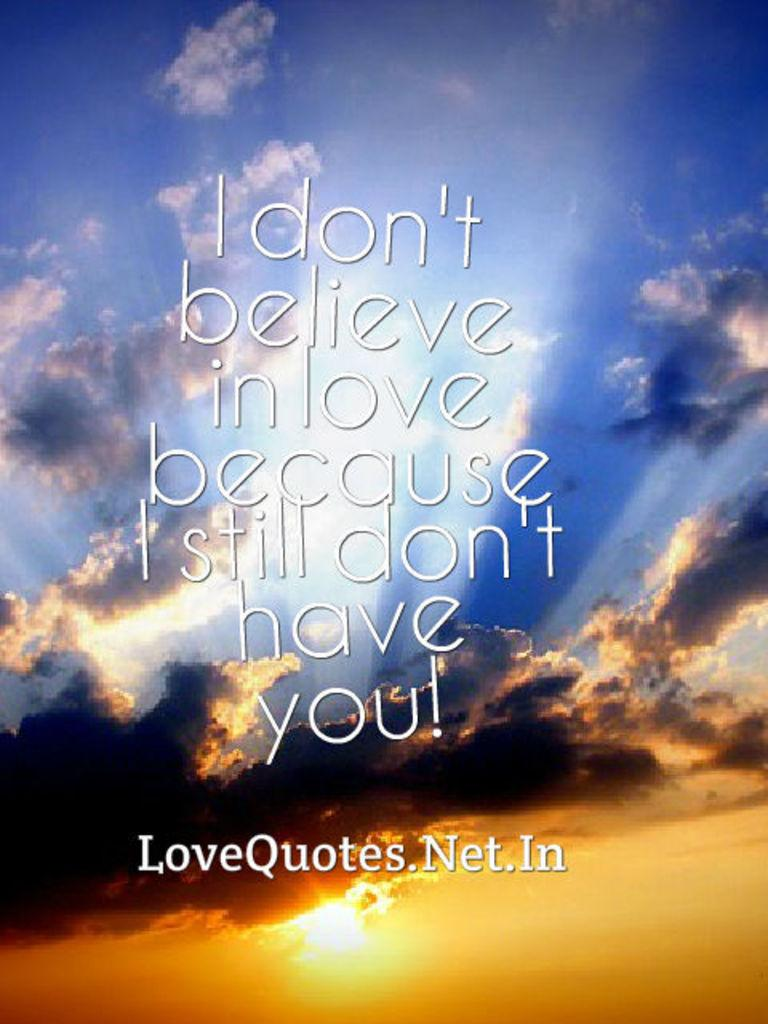What can be seen on the image? There is writing on the image. What is visible in the background of the image? There is sky visible in the background of the image. What can be observed in the sky? Clouds are present in the sky. What type of bulb is illuminating the writing in the image? There is no bulb present in the image; the writing is not being illuminated by any light source. Can you see any cracks in the writing on the image? The provided facts do not mention any cracks in the writing, so we cannot determine if any are present. 